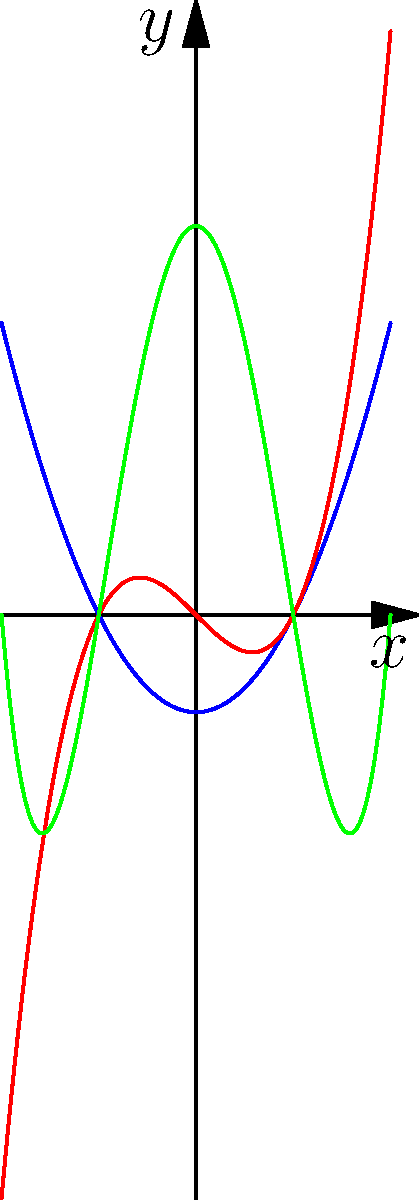Consider the polynomial graphs shown above. How does the degree of a polynomial relate to the maximum number of roots (x-intercepts) it can have? Which of these polynomials demonstrates this relationship most clearly, and how might this reflect God's design in mathematical patterns? Let's approach this step-by-step:

1. The blue curve represents $y=x^2-1$, a quadratic (degree 2) polynomial.
2. The red curve represents $y=x^3-x$, a cubic (degree 3) polynomial.
3. The green curve represents $y=x^4-5x^2+4$, a quartic (degree 4) polynomial.

4. The Fundamental Theorem of Algebra states that a polynomial of degree n has exactly n complex roots, counting multiplicity.

5. For real roots (x-intercepts):
   - The quadratic has 2 roots
   - The cubic has 3 roots
   - The quartic has 4 roots

6. This demonstrates that the maximum number of real roots a polynomial can have is equal to its degree.

7. The green quartic polynomial ($y=x^4-5x^2+4$) most clearly demonstrates this relationship, as it visibly crosses the x-axis 4 times, matching its degree.

8. From a Christian perspective, this mathematical pattern could be seen as a reflection of God's orderly design in creation. Just as God established natural laws, He also established mathematical truths that reveal the beauty and consistency of His creation.
Answer: The maximum number of real roots equals the polynomial's degree; the quartic (green) best demonstrates this. 